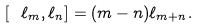<formula> <loc_0><loc_0><loc_500><loc_500>[ \ \ell _ { m } , \ell _ { n } ] = ( m - n ) \ell _ { m + n } .</formula> 